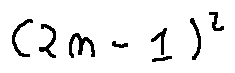<formula> <loc_0><loc_0><loc_500><loc_500>( 2 n - 1 ) ^ { 2 }</formula> 